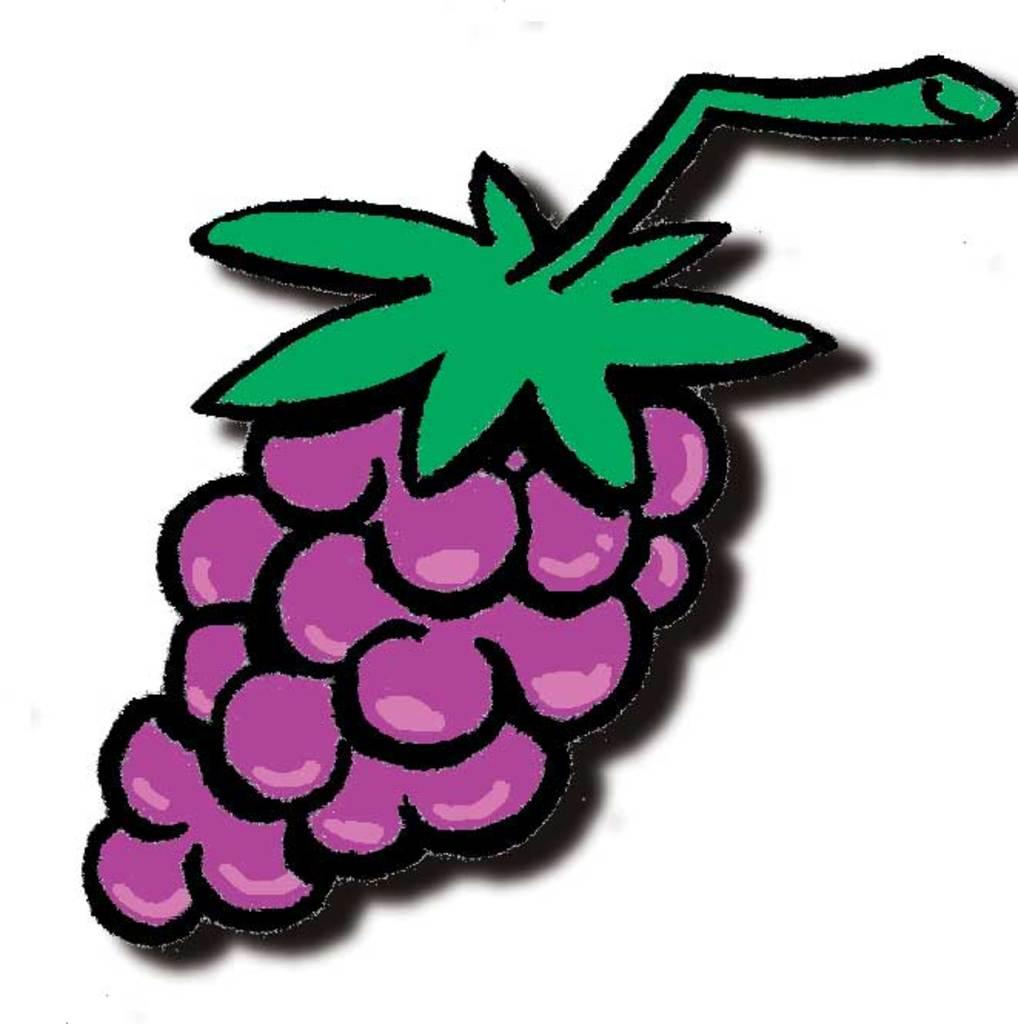What is the main subject of the art in the image? The main subject of the art in the image is grapes. What color are the grapes depicted in the art? The grapes are depicted in purple color. What color are the leaves in the art? The leaves in the art are in green color. What color is the background of the image? The background of the image is white. How does the theory of relativity relate to the art of grapes in the image? The theory of relativity does not relate to the art of grapes in the image, as it is a scientific concept unrelated to the visual representation of grapes and leaves. 